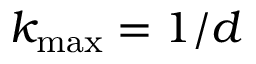Convert formula to latex. <formula><loc_0><loc_0><loc_500><loc_500>k _ { \max } = 1 / d</formula> 